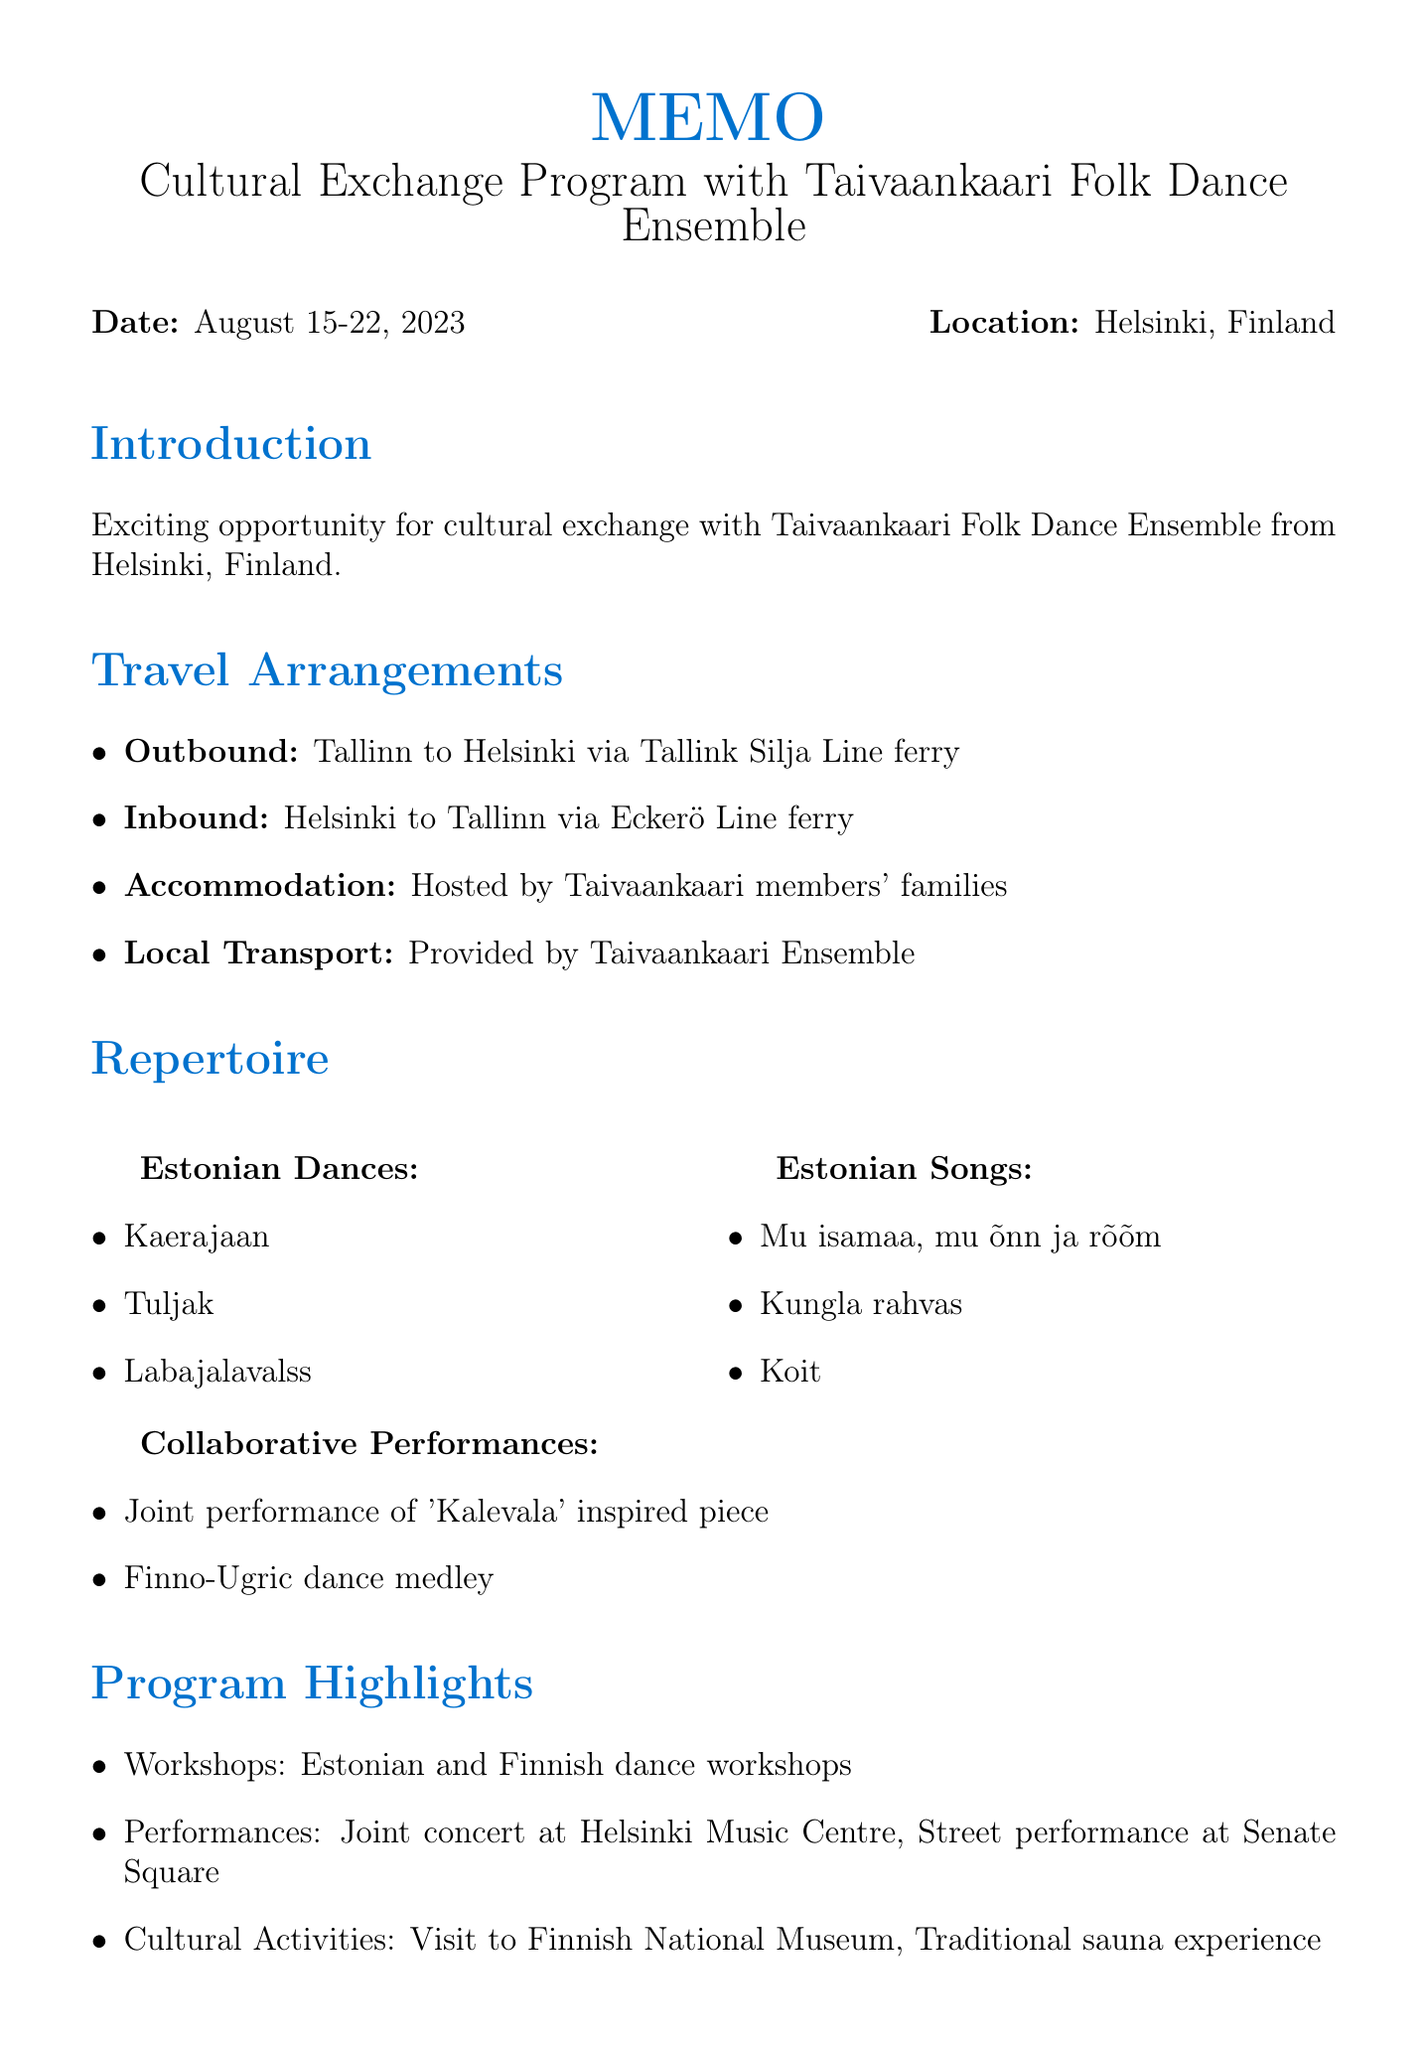What is the name of the Finnish folk dance troupe? The document mentions that the cultural exchange is with the Taivaankaari Folk Dance Ensemble.
Answer: Taivaankaari Folk Dance Ensemble What are the proposed dates for the exchange? The dates for the proposed exchange are stated in the introduction section of the memo as August 15-22, 2023.
Answer: August 15-22, 2023 How many dancers and musicians are in the group size? The logistics section specifies that the group size consists of 12 dancers and 3 musicians from our ensemble, totaling 15 individuals.
Answer: 12 dancers and 3 musicians What type of ferry is used for outbound transportation? The memo specifies that the outbound transportation is via Tallink Silja Line ferry.
Answer: Tallink Silja Line ferry What cultural activity involves a sauna experience? The program highlights section notes a traditional sauna experience as part of the cultural activities during the exchange.
Answer: Traditional sauna experience Which Estonian song is listed first in the potential repertoire? The potential repertoire section includes a list of Estonian songs, with "Mu isamaa, mu õnn ja rõõm" being the first song mentioned.
Answer: Mu isamaa, mu õnn ja rõõm Who is the Finnish coordinator for the program? The contact information section provides the name of the Finnish coordinator as Liisa Virtanen.
Answer: Liisa Virtanen What is one of the joint performances mentioned? In the potential repertoire section, a joint performance of a 'Kalevala' inspired piece is listed as an upcoming collaboration.
Answer: Joint performance of 'Kalevala' inspired piece 